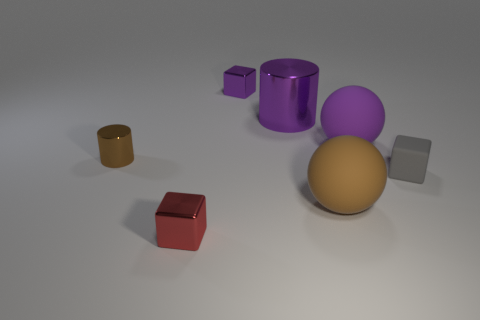Is the number of small shiny objects to the left of the tiny red cube greater than the number of red metal things behind the purple cylinder?
Your answer should be compact. Yes. What is the tiny object that is behind the large purple rubber ball made of?
Your response must be concise. Metal. Do the small gray thing and the big brown thing have the same shape?
Provide a succinct answer. No. Is there anything else of the same color as the small rubber thing?
Keep it short and to the point. No. There is another object that is the same shape as the big purple metallic thing; what color is it?
Provide a short and direct response. Brown. Are there more tiny metal blocks in front of the purple cylinder than small blue matte balls?
Give a very brief answer. Yes. What is the color of the metal block behind the big metallic cylinder?
Offer a terse response. Purple. Is the size of the purple rubber thing the same as the brown shiny thing?
Provide a succinct answer. No. What is the size of the gray cube?
Your answer should be very brief. Small. There is a large thing that is the same color as the big cylinder; what is its shape?
Your answer should be compact. Sphere. 